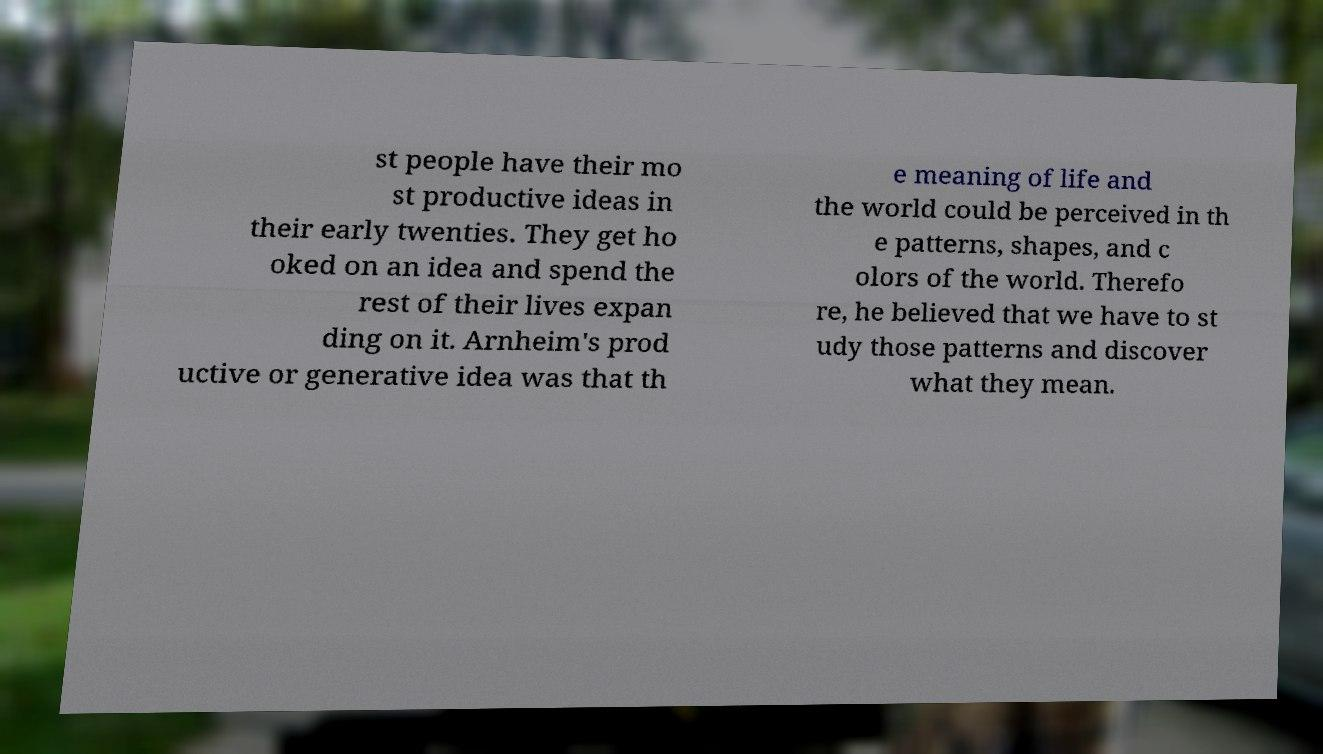Please identify and transcribe the text found in this image. st people have their mo st productive ideas in their early twenties. They get ho oked on an idea and spend the rest of their lives expan ding on it. Arnheim's prod uctive or generative idea was that th e meaning of life and the world could be perceived in th e patterns, shapes, and c olors of the world. Therefo re, he believed that we have to st udy those patterns and discover what they mean. 